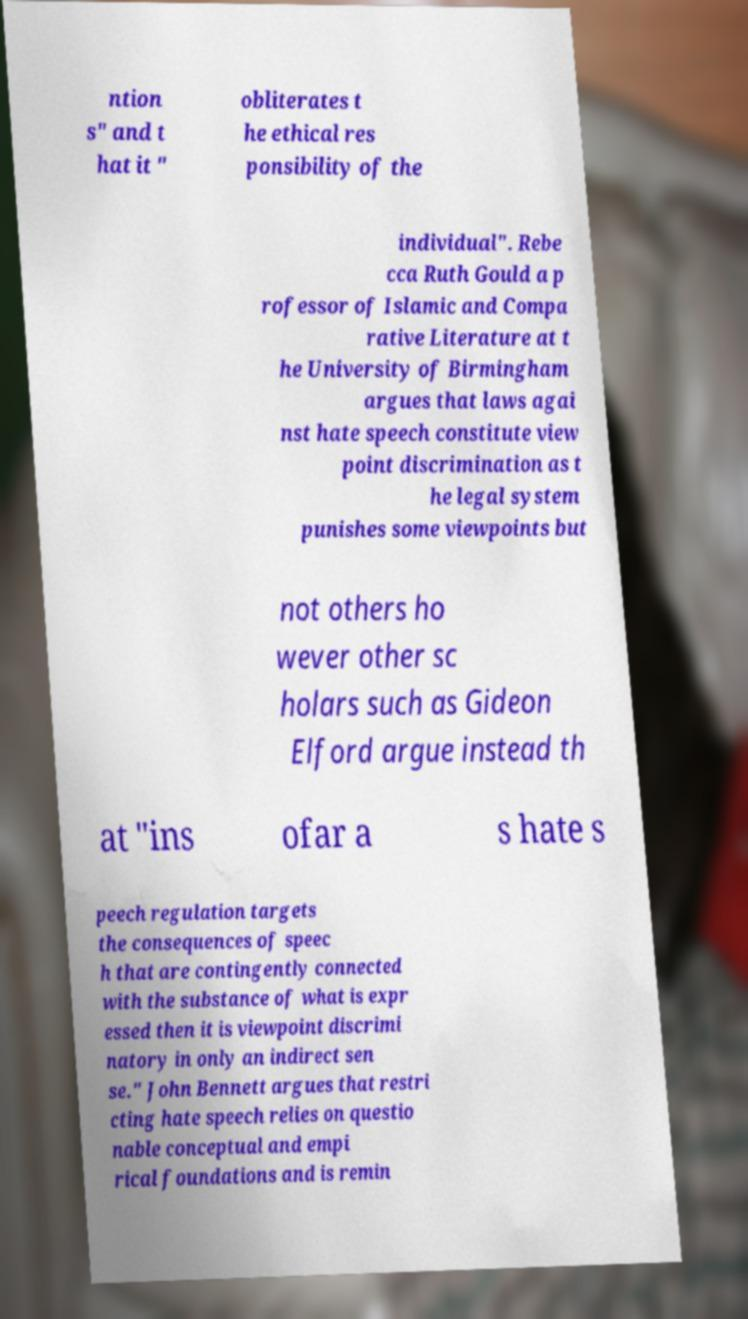Could you assist in decoding the text presented in this image and type it out clearly? ntion s" and t hat it " obliterates t he ethical res ponsibility of the individual". Rebe cca Ruth Gould a p rofessor of Islamic and Compa rative Literature at t he University of Birmingham argues that laws agai nst hate speech constitute view point discrimination as t he legal system punishes some viewpoints but not others ho wever other sc holars such as Gideon Elford argue instead th at "ins ofar a s hate s peech regulation targets the consequences of speec h that are contingently connected with the substance of what is expr essed then it is viewpoint discrimi natory in only an indirect sen se." John Bennett argues that restri cting hate speech relies on questio nable conceptual and empi rical foundations and is remin 